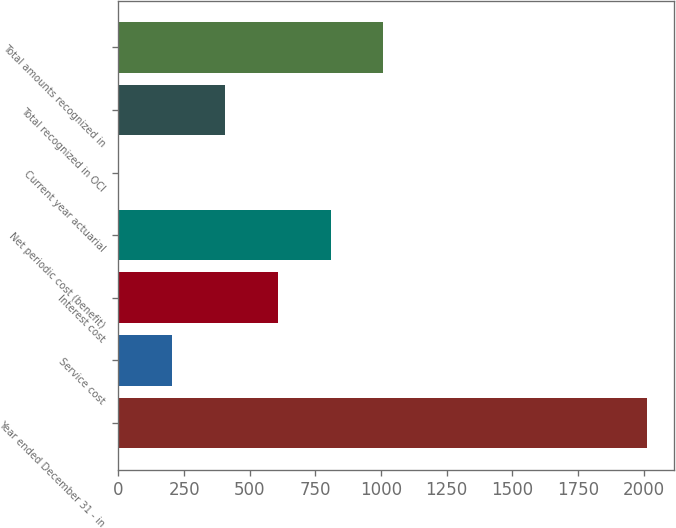Convert chart. <chart><loc_0><loc_0><loc_500><loc_500><bar_chart><fcel>Year ended December 31 - in<fcel>Service cost<fcel>Interest cost<fcel>Net periodic cost (benefit)<fcel>Current year actuarial<fcel>Total recognized in OCI<fcel>Total amounts recognized in<nl><fcel>2014<fcel>205<fcel>607<fcel>808<fcel>4<fcel>406<fcel>1009<nl></chart> 